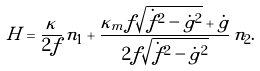Convert formula to latex. <formula><loc_0><loc_0><loc_500><loc_500>H = \frac { \kappa } { 2 f } \, n _ { 1 } + \frac { \kappa _ { m } f \sqrt { \dot { f } ^ { 2 } - \dot { g } ^ { 2 } } + \dot { g } } { 2 f \sqrt { \dot { f } ^ { 2 } - \dot { g } ^ { 2 } } } \, n _ { 2 } .</formula> 